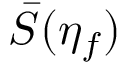Convert formula to latex. <formula><loc_0><loc_0><loc_500><loc_500>\bar { S } ( \eta _ { f } )</formula> 